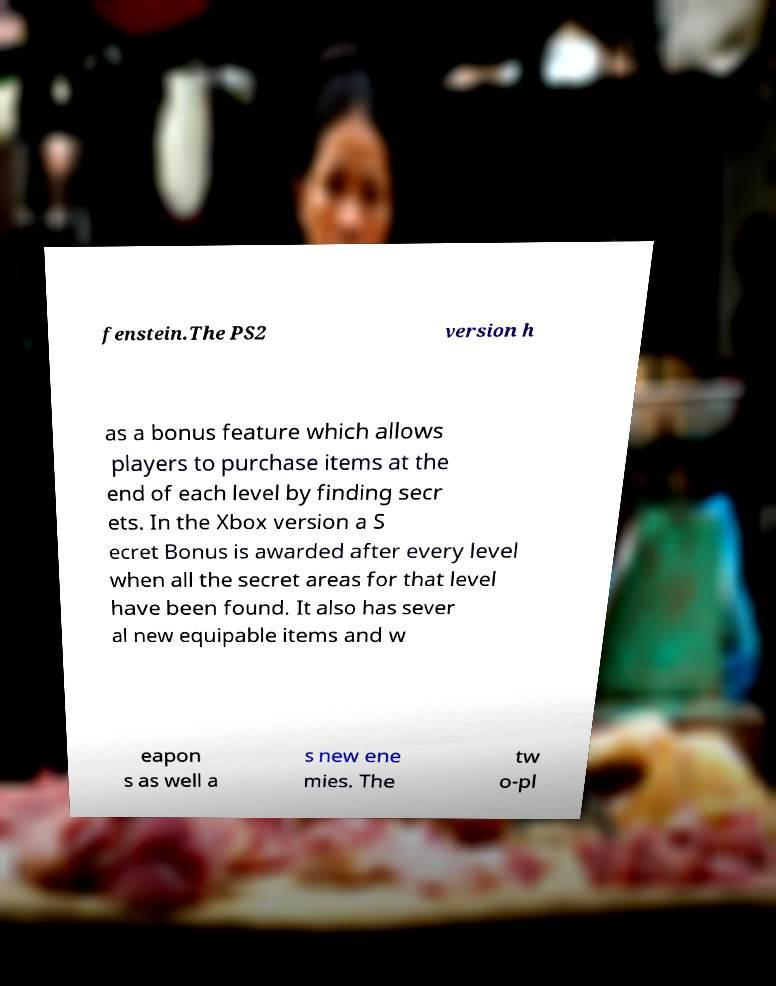What messages or text are displayed in this image? I need them in a readable, typed format. fenstein.The PS2 version h as a bonus feature which allows players to purchase items at the end of each level by finding secr ets. In the Xbox version a S ecret Bonus is awarded after every level when all the secret areas for that level have been found. It also has sever al new equipable items and w eapon s as well a s new ene mies. The tw o-pl 